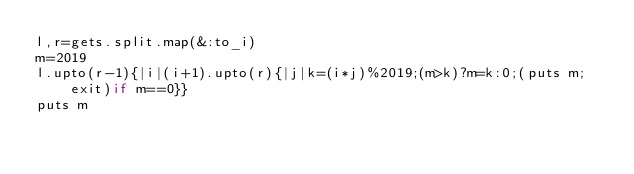Convert code to text. <code><loc_0><loc_0><loc_500><loc_500><_Ruby_>l,r=gets.split.map(&:to_i)
m=2019
l.upto(r-1){|i|(i+1).upto(r){|j|k=(i*j)%2019;(m>k)?m=k:0;(puts m;exit)if m==0}}
puts m</code> 